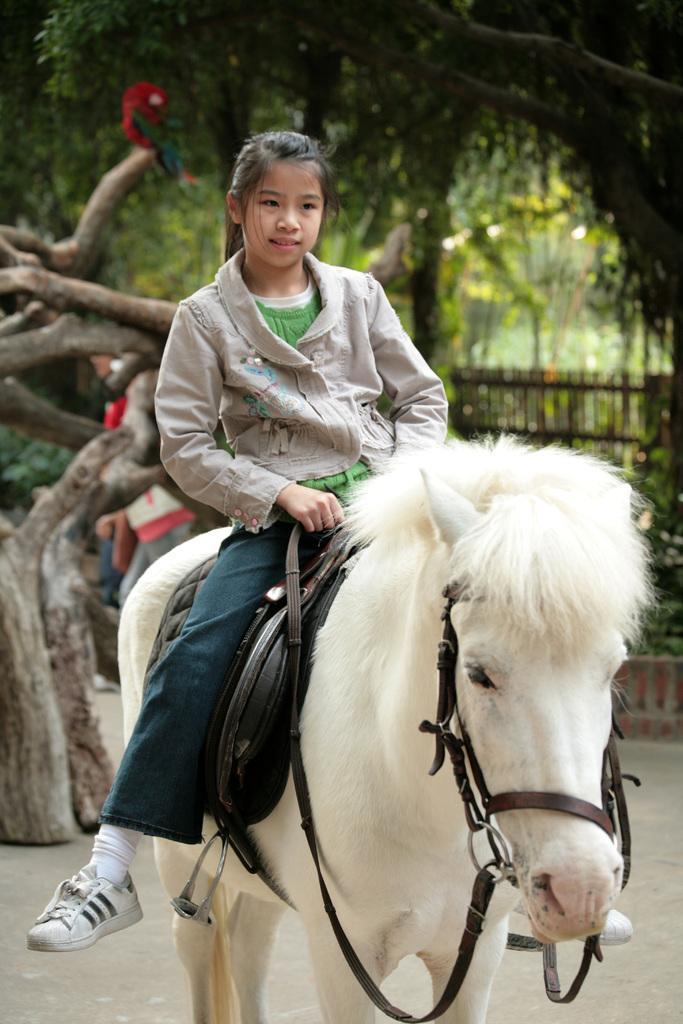Please provide a concise description of this image. This image consists of a white horse. On that there is a girl sitting. There are trees at the top. 